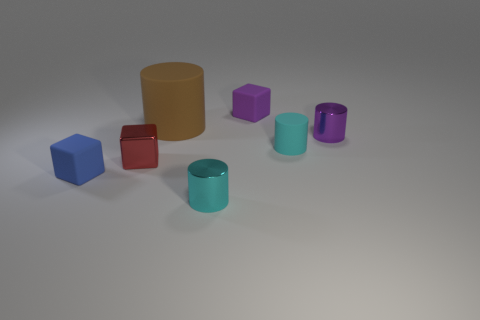Add 1 blue things. How many objects exist? 8 Subtract all cylinders. How many objects are left? 3 Subtract all tiny cubes. Subtract all big gray spheres. How many objects are left? 4 Add 2 metal objects. How many metal objects are left? 5 Add 7 red shiny spheres. How many red shiny spheres exist? 7 Subtract 0 cyan spheres. How many objects are left? 7 